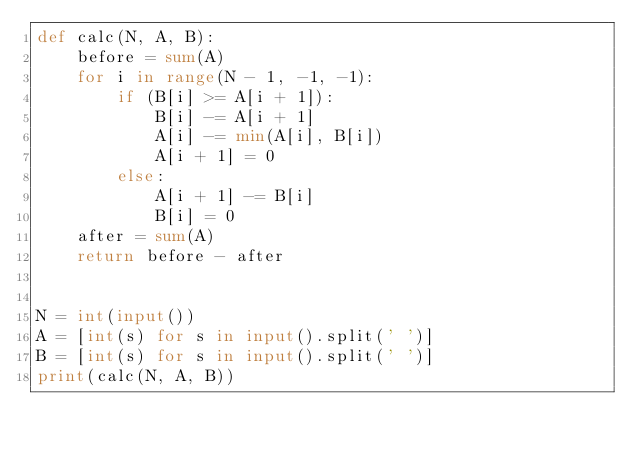Convert code to text. <code><loc_0><loc_0><loc_500><loc_500><_Python_>def calc(N, A, B):
    before = sum(A)
    for i in range(N - 1, -1, -1):
        if (B[i] >= A[i + 1]):
            B[i] -= A[i + 1]
            A[i] -= min(A[i], B[i])
            A[i + 1] = 0
        else:
            A[i + 1] -= B[i]
            B[i] = 0
    after = sum(A)
    return before - after


N = int(input())
A = [int(s) for s in input().split(' ')]
B = [int(s) for s in input().split(' ')]
print(calc(N, A, B))</code> 